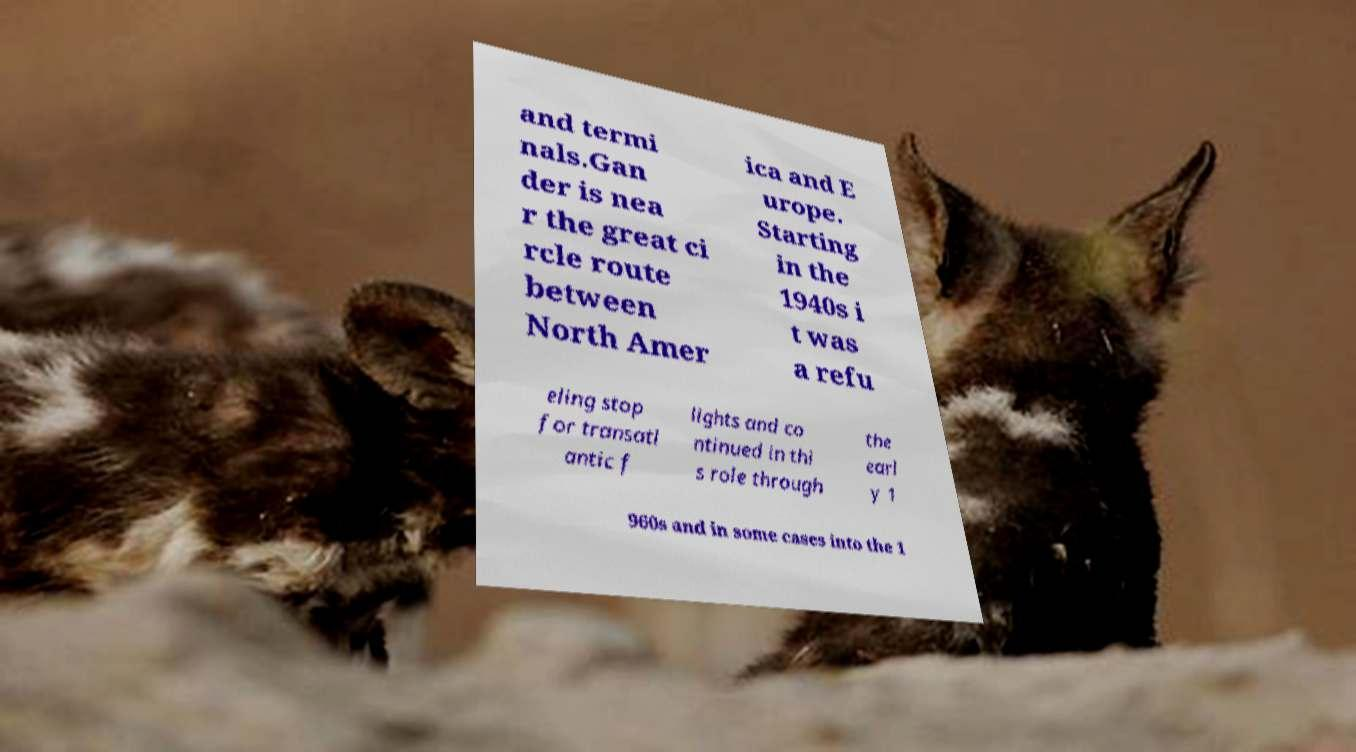Could you assist in decoding the text presented in this image and type it out clearly? and termi nals.Gan der is nea r the great ci rcle route between North Amer ica and E urope. Starting in the 1940s i t was a refu eling stop for transatl antic f lights and co ntinued in thi s role through the earl y 1 960s and in some cases into the 1 